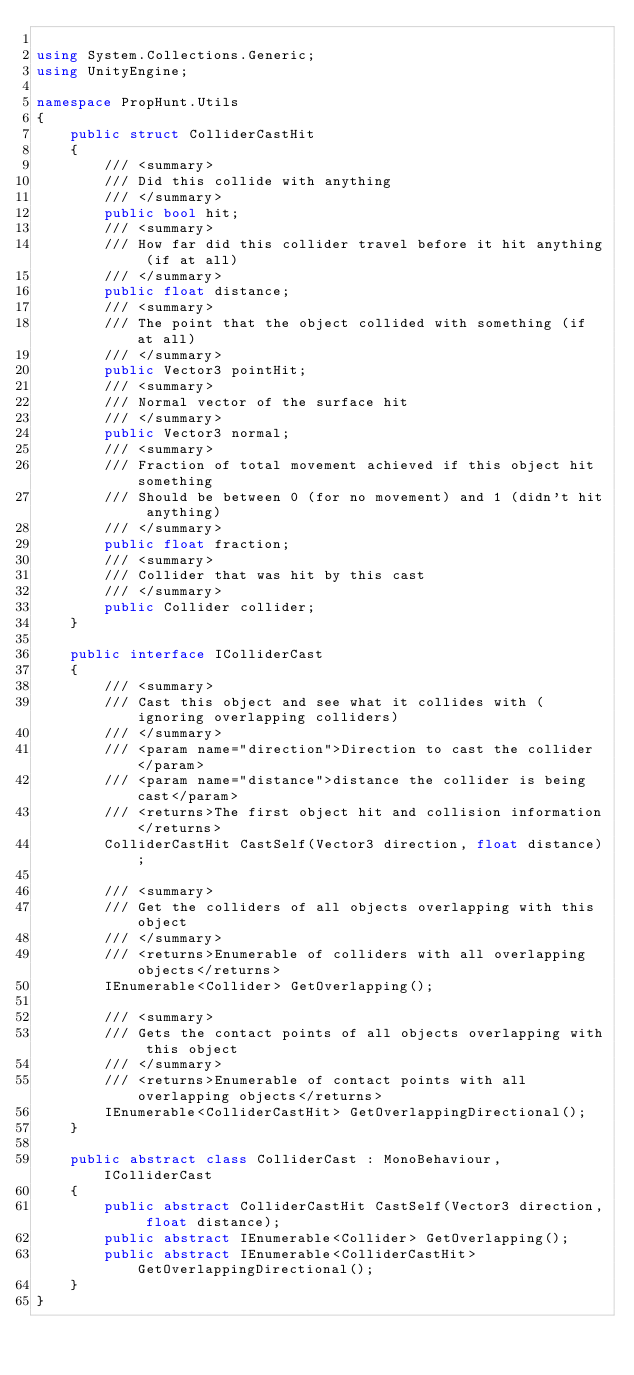Convert code to text. <code><loc_0><loc_0><loc_500><loc_500><_C#_>
using System.Collections.Generic;
using UnityEngine;

namespace PropHunt.Utils
{
    public struct ColliderCastHit
    {
        /// <summary>
        /// Did this collide with anything
        /// </summary>
        public bool hit;
        /// <summary>
        /// How far did this collider travel before it hit anything (if at all)
        /// </summary>
        public float distance;
        /// <summary>
        /// The point that the object collided with something (if at all)
        /// </summary>
        public Vector3 pointHit;
        /// <summary>
        /// Normal vector of the surface hit
        /// </summary>
        public Vector3 normal;
        /// <summary>
        /// Fraction of total movement achieved if this object hit something
        /// Should be between 0 (for no movement) and 1 (didn't hit anything)
        /// </summary>
        public float fraction;
        /// <summary>
        /// Collider that was hit by this cast
        /// </summary>
        public Collider collider;
    }

    public interface IColliderCast
    {
        /// <summary>
        /// Cast this object and see what it collides with (ignoring overlapping colliders)
        /// </summary>
        /// <param name="direction">Direction to cast the collider</param>
        /// <param name="distance">distance the collider is being cast</param>
        /// <returns>The first object hit and collision information</returns>
        ColliderCastHit CastSelf(Vector3 direction, float distance);

        /// <summary>
        /// Get the colliders of all objects overlapping with this object
        /// </summary>
        /// <returns>Enumerable of colliders with all overlapping objects</returns>
        IEnumerable<Collider> GetOverlapping();

        /// <summary>
        /// Gets the contact points of all objects overlapping with this object
        /// </summary>
        /// <returns>Enumerable of contact points with all overlapping objects</returns>
        IEnumerable<ColliderCastHit> GetOverlappingDirectional();
    }

    public abstract class ColliderCast : MonoBehaviour, IColliderCast
    {
        public abstract ColliderCastHit CastSelf(Vector3 direction, float distance);
        public abstract IEnumerable<Collider> GetOverlapping();
        public abstract IEnumerable<ColliderCastHit> GetOverlappingDirectional();
    }
}
</code> 